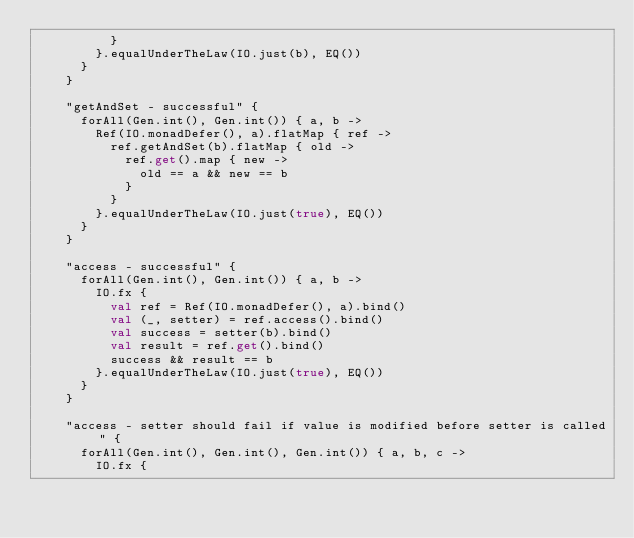<code> <loc_0><loc_0><loc_500><loc_500><_Kotlin_>          }
        }.equalUnderTheLaw(IO.just(b), EQ())
      }
    }

    "getAndSet - successful" {
      forAll(Gen.int(), Gen.int()) { a, b ->
        Ref(IO.monadDefer(), a).flatMap { ref ->
          ref.getAndSet(b).flatMap { old ->
            ref.get().map { new ->
              old == a && new == b
            }
          }
        }.equalUnderTheLaw(IO.just(true), EQ())
      }
    }

    "access - successful" {
      forAll(Gen.int(), Gen.int()) { a, b ->
        IO.fx {
          val ref = Ref(IO.monadDefer(), a).bind()
          val (_, setter) = ref.access().bind()
          val success = setter(b).bind()
          val result = ref.get().bind()
          success && result == b
        }.equalUnderTheLaw(IO.just(true), EQ())
      }
    }

    "access - setter should fail if value is modified before setter is called" {
      forAll(Gen.int(), Gen.int(), Gen.int()) { a, b, c ->
        IO.fx {</code> 